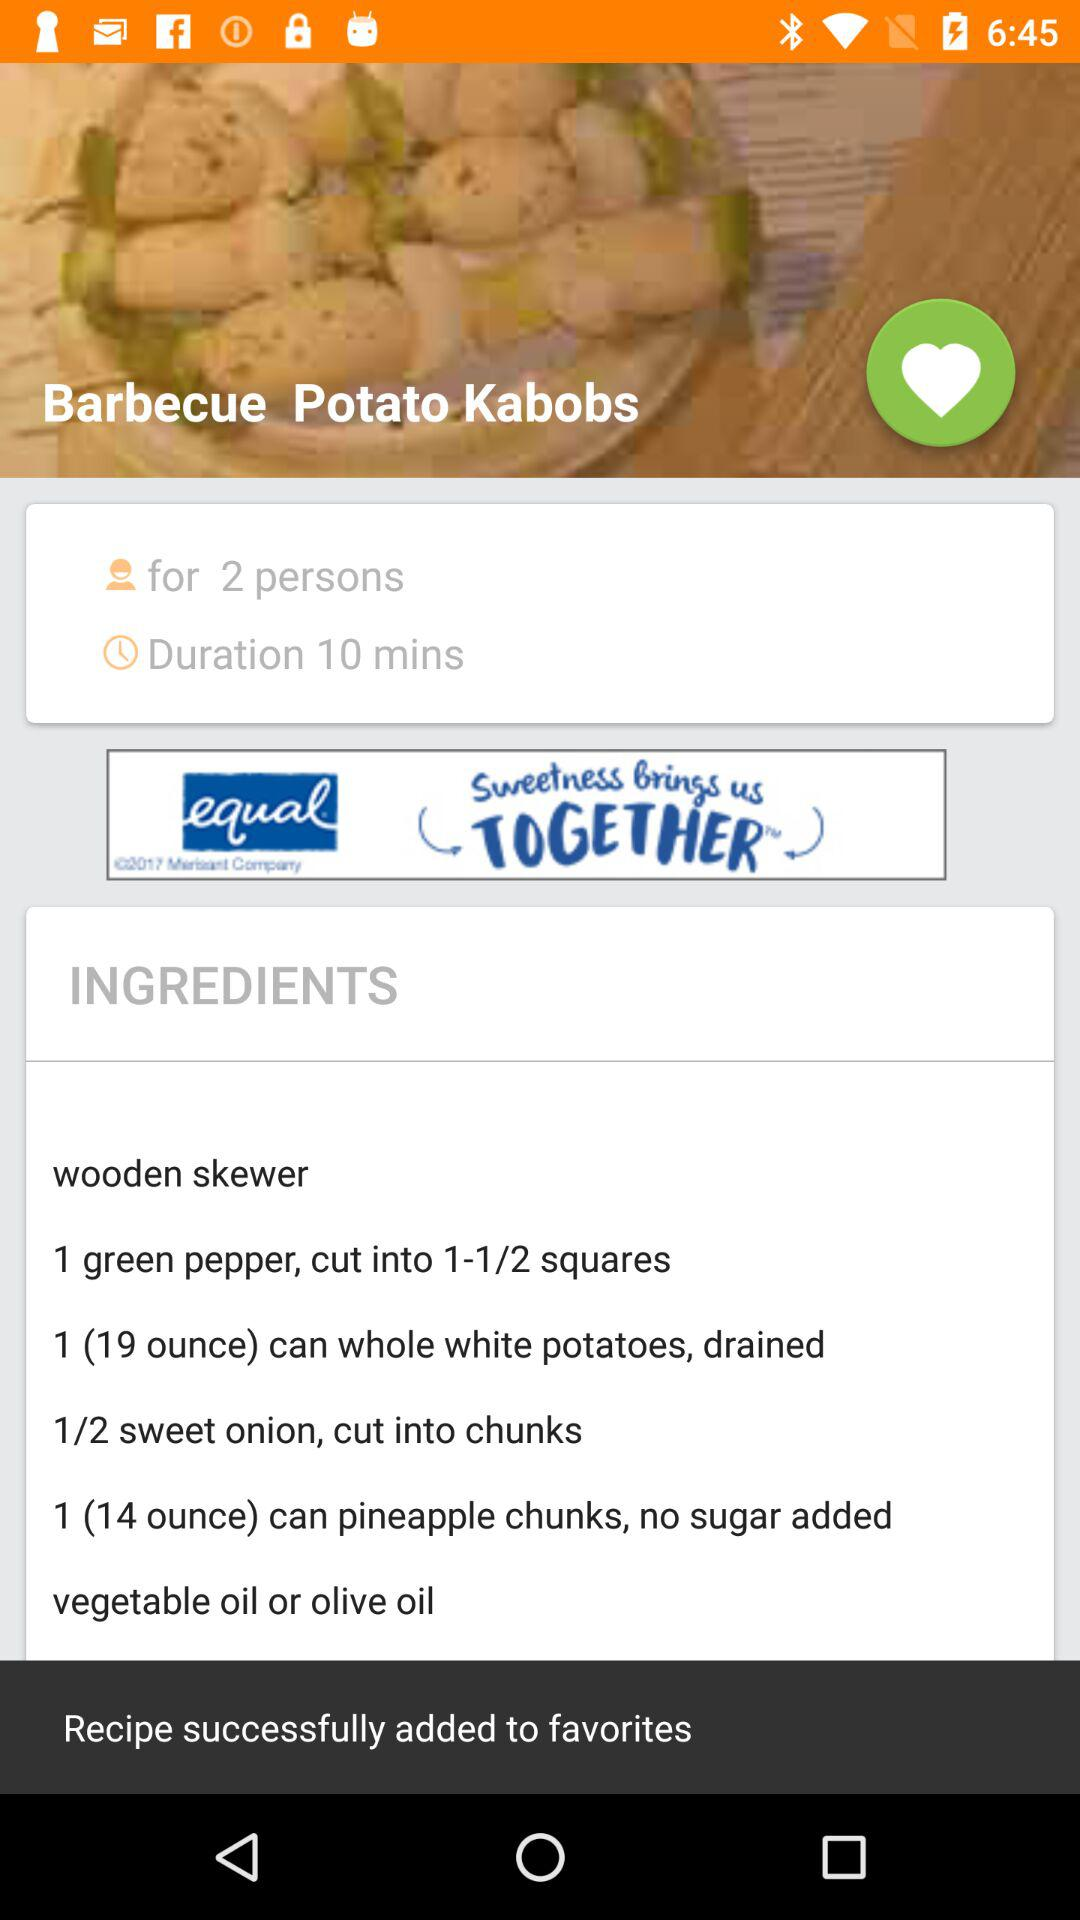What is the duration for "Barbecue Potato kabobs"? The duration is 10 minutes. 